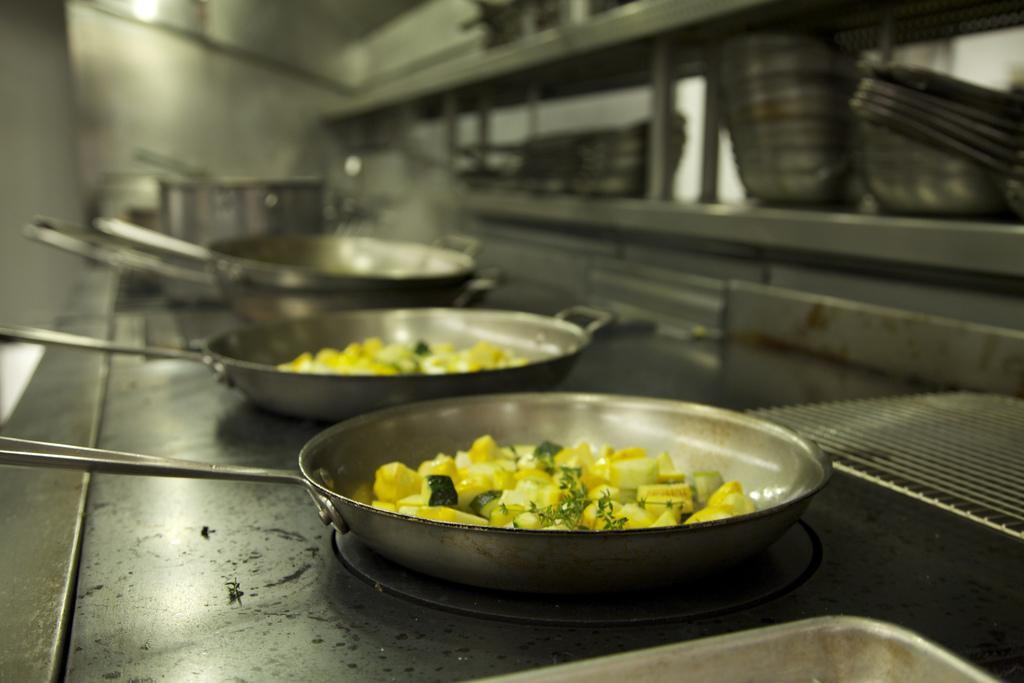Could you give a brief overview of what you see in this image? In this image there are food items in a pan on the stove. In front of the stove there are some utensils on the shelf's. At the top of the image there is a lamp. 